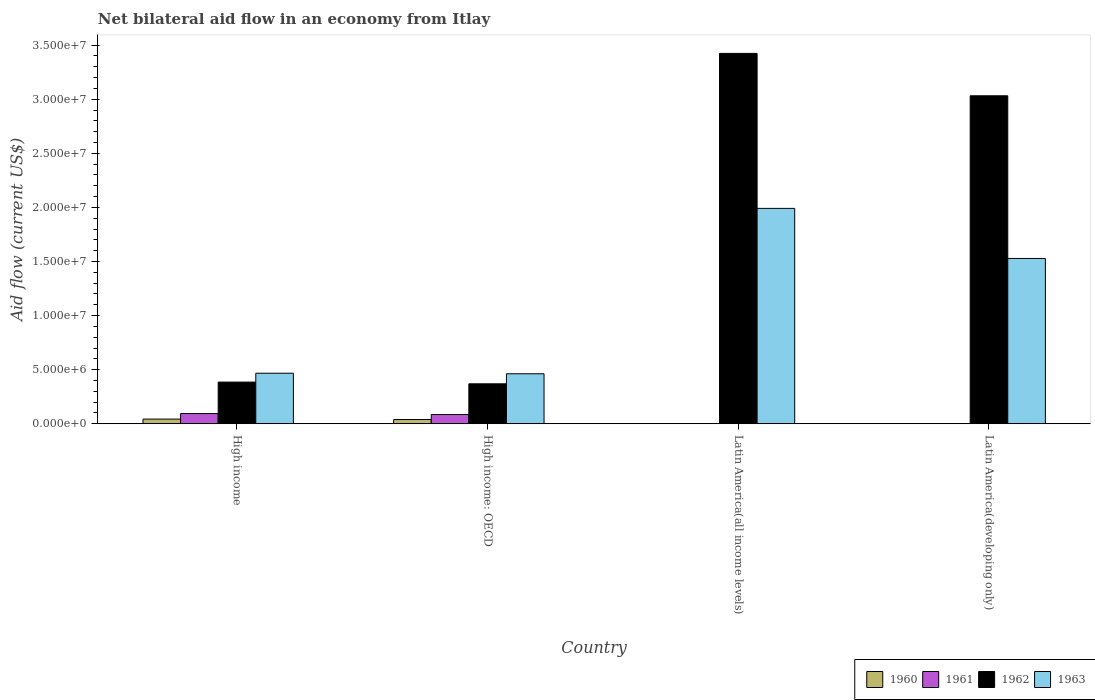How many groups of bars are there?
Offer a very short reply. 4. Are the number of bars per tick equal to the number of legend labels?
Keep it short and to the point. No. How many bars are there on the 1st tick from the left?
Provide a succinct answer. 4. How many bars are there on the 2nd tick from the right?
Provide a short and direct response. 2. What is the label of the 3rd group of bars from the left?
Provide a succinct answer. Latin America(all income levels). In how many cases, is the number of bars for a given country not equal to the number of legend labels?
Your response must be concise. 2. What is the net bilateral aid flow in 1963 in High income?
Your response must be concise. 4.67e+06. Across all countries, what is the maximum net bilateral aid flow in 1962?
Your response must be concise. 3.42e+07. Across all countries, what is the minimum net bilateral aid flow in 1960?
Your response must be concise. 0. In which country was the net bilateral aid flow in 1962 maximum?
Provide a short and direct response. Latin America(all income levels). What is the total net bilateral aid flow in 1962 in the graph?
Give a very brief answer. 7.21e+07. What is the difference between the net bilateral aid flow in 1961 in High income and that in High income: OECD?
Your answer should be compact. 9.00e+04. What is the difference between the net bilateral aid flow in 1962 in Latin America(developing only) and the net bilateral aid flow in 1961 in High income: OECD?
Provide a succinct answer. 2.95e+07. What is the average net bilateral aid flow in 1961 per country?
Offer a very short reply. 4.48e+05. What is the difference between the net bilateral aid flow of/in 1963 and net bilateral aid flow of/in 1962 in High income?
Keep it short and to the point. 8.20e+05. In how many countries, is the net bilateral aid flow in 1961 greater than 25000000 US$?
Your answer should be compact. 0. What is the ratio of the net bilateral aid flow in 1962 in High income to that in Latin America(developing only)?
Offer a terse response. 0.13. Is the net bilateral aid flow in 1960 in High income less than that in High income: OECD?
Offer a very short reply. No. What is the difference between the highest and the second highest net bilateral aid flow in 1962?
Your answer should be very brief. 3.04e+07. What is the difference between the highest and the lowest net bilateral aid flow in 1962?
Provide a succinct answer. 3.06e+07. Is the sum of the net bilateral aid flow in 1962 in High income and Latin America(all income levels) greater than the maximum net bilateral aid flow in 1963 across all countries?
Ensure brevity in your answer.  Yes. Is it the case that in every country, the sum of the net bilateral aid flow in 1963 and net bilateral aid flow in 1960 is greater than the sum of net bilateral aid flow in 1961 and net bilateral aid flow in 1962?
Make the answer very short. No. Is it the case that in every country, the sum of the net bilateral aid flow in 1963 and net bilateral aid flow in 1961 is greater than the net bilateral aid flow in 1960?
Give a very brief answer. Yes. Are all the bars in the graph horizontal?
Provide a succinct answer. No. How many countries are there in the graph?
Your answer should be very brief. 4. What is the difference between two consecutive major ticks on the Y-axis?
Ensure brevity in your answer.  5.00e+06. Does the graph contain any zero values?
Provide a succinct answer. Yes. How many legend labels are there?
Offer a very short reply. 4. How are the legend labels stacked?
Offer a terse response. Horizontal. What is the title of the graph?
Your response must be concise. Net bilateral aid flow in an economy from Itlay. What is the label or title of the X-axis?
Offer a very short reply. Country. What is the label or title of the Y-axis?
Your answer should be compact. Aid flow (current US$). What is the Aid flow (current US$) of 1960 in High income?
Your response must be concise. 4.30e+05. What is the Aid flow (current US$) of 1961 in High income?
Provide a succinct answer. 9.40e+05. What is the Aid flow (current US$) of 1962 in High income?
Offer a very short reply. 3.85e+06. What is the Aid flow (current US$) of 1963 in High income?
Offer a terse response. 4.67e+06. What is the Aid flow (current US$) of 1961 in High income: OECD?
Offer a very short reply. 8.50e+05. What is the Aid flow (current US$) of 1962 in High income: OECD?
Offer a very short reply. 3.69e+06. What is the Aid flow (current US$) in 1963 in High income: OECD?
Your response must be concise. 4.62e+06. What is the Aid flow (current US$) in 1961 in Latin America(all income levels)?
Give a very brief answer. 0. What is the Aid flow (current US$) in 1962 in Latin America(all income levels)?
Make the answer very short. 3.42e+07. What is the Aid flow (current US$) in 1963 in Latin America(all income levels)?
Offer a very short reply. 1.99e+07. What is the Aid flow (current US$) in 1960 in Latin America(developing only)?
Keep it short and to the point. 0. What is the Aid flow (current US$) in 1962 in Latin America(developing only)?
Make the answer very short. 3.03e+07. What is the Aid flow (current US$) in 1963 in Latin America(developing only)?
Keep it short and to the point. 1.53e+07. Across all countries, what is the maximum Aid flow (current US$) of 1961?
Give a very brief answer. 9.40e+05. Across all countries, what is the maximum Aid flow (current US$) in 1962?
Offer a very short reply. 3.42e+07. Across all countries, what is the maximum Aid flow (current US$) of 1963?
Ensure brevity in your answer.  1.99e+07. Across all countries, what is the minimum Aid flow (current US$) of 1960?
Keep it short and to the point. 0. Across all countries, what is the minimum Aid flow (current US$) in 1962?
Offer a terse response. 3.69e+06. Across all countries, what is the minimum Aid flow (current US$) in 1963?
Your response must be concise. 4.62e+06. What is the total Aid flow (current US$) in 1960 in the graph?
Provide a short and direct response. 8.20e+05. What is the total Aid flow (current US$) of 1961 in the graph?
Ensure brevity in your answer.  1.79e+06. What is the total Aid flow (current US$) in 1962 in the graph?
Provide a succinct answer. 7.21e+07. What is the total Aid flow (current US$) of 1963 in the graph?
Your answer should be compact. 4.45e+07. What is the difference between the Aid flow (current US$) in 1960 in High income and that in High income: OECD?
Make the answer very short. 4.00e+04. What is the difference between the Aid flow (current US$) of 1961 in High income and that in High income: OECD?
Your answer should be very brief. 9.00e+04. What is the difference between the Aid flow (current US$) of 1962 in High income and that in High income: OECD?
Ensure brevity in your answer.  1.60e+05. What is the difference between the Aid flow (current US$) of 1963 in High income and that in High income: OECD?
Offer a terse response. 5.00e+04. What is the difference between the Aid flow (current US$) in 1962 in High income and that in Latin America(all income levels)?
Provide a short and direct response. -3.04e+07. What is the difference between the Aid flow (current US$) in 1963 in High income and that in Latin America(all income levels)?
Give a very brief answer. -1.52e+07. What is the difference between the Aid flow (current US$) of 1962 in High income and that in Latin America(developing only)?
Offer a terse response. -2.65e+07. What is the difference between the Aid flow (current US$) in 1963 in High income and that in Latin America(developing only)?
Make the answer very short. -1.06e+07. What is the difference between the Aid flow (current US$) of 1962 in High income: OECD and that in Latin America(all income levels)?
Your answer should be very brief. -3.06e+07. What is the difference between the Aid flow (current US$) of 1963 in High income: OECD and that in Latin America(all income levels)?
Offer a terse response. -1.53e+07. What is the difference between the Aid flow (current US$) of 1962 in High income: OECD and that in Latin America(developing only)?
Make the answer very short. -2.66e+07. What is the difference between the Aid flow (current US$) in 1963 in High income: OECD and that in Latin America(developing only)?
Provide a short and direct response. -1.07e+07. What is the difference between the Aid flow (current US$) in 1962 in Latin America(all income levels) and that in Latin America(developing only)?
Give a very brief answer. 3.92e+06. What is the difference between the Aid flow (current US$) of 1963 in Latin America(all income levels) and that in Latin America(developing only)?
Offer a terse response. 4.63e+06. What is the difference between the Aid flow (current US$) of 1960 in High income and the Aid flow (current US$) of 1961 in High income: OECD?
Give a very brief answer. -4.20e+05. What is the difference between the Aid flow (current US$) in 1960 in High income and the Aid flow (current US$) in 1962 in High income: OECD?
Offer a very short reply. -3.26e+06. What is the difference between the Aid flow (current US$) of 1960 in High income and the Aid flow (current US$) of 1963 in High income: OECD?
Give a very brief answer. -4.19e+06. What is the difference between the Aid flow (current US$) in 1961 in High income and the Aid flow (current US$) in 1962 in High income: OECD?
Your response must be concise. -2.75e+06. What is the difference between the Aid flow (current US$) in 1961 in High income and the Aid flow (current US$) in 1963 in High income: OECD?
Make the answer very short. -3.68e+06. What is the difference between the Aid flow (current US$) of 1962 in High income and the Aid flow (current US$) of 1963 in High income: OECD?
Your response must be concise. -7.70e+05. What is the difference between the Aid flow (current US$) in 1960 in High income and the Aid flow (current US$) in 1962 in Latin America(all income levels)?
Provide a short and direct response. -3.38e+07. What is the difference between the Aid flow (current US$) of 1960 in High income and the Aid flow (current US$) of 1963 in Latin America(all income levels)?
Provide a succinct answer. -1.95e+07. What is the difference between the Aid flow (current US$) of 1961 in High income and the Aid flow (current US$) of 1962 in Latin America(all income levels)?
Your response must be concise. -3.33e+07. What is the difference between the Aid flow (current US$) of 1961 in High income and the Aid flow (current US$) of 1963 in Latin America(all income levels)?
Offer a very short reply. -1.90e+07. What is the difference between the Aid flow (current US$) of 1962 in High income and the Aid flow (current US$) of 1963 in Latin America(all income levels)?
Provide a succinct answer. -1.61e+07. What is the difference between the Aid flow (current US$) of 1960 in High income and the Aid flow (current US$) of 1962 in Latin America(developing only)?
Your response must be concise. -2.99e+07. What is the difference between the Aid flow (current US$) in 1960 in High income and the Aid flow (current US$) in 1963 in Latin America(developing only)?
Provide a short and direct response. -1.48e+07. What is the difference between the Aid flow (current US$) in 1961 in High income and the Aid flow (current US$) in 1962 in Latin America(developing only)?
Offer a terse response. -2.94e+07. What is the difference between the Aid flow (current US$) in 1961 in High income and the Aid flow (current US$) in 1963 in Latin America(developing only)?
Provide a succinct answer. -1.43e+07. What is the difference between the Aid flow (current US$) of 1962 in High income and the Aid flow (current US$) of 1963 in Latin America(developing only)?
Your answer should be compact. -1.14e+07. What is the difference between the Aid flow (current US$) of 1960 in High income: OECD and the Aid flow (current US$) of 1962 in Latin America(all income levels)?
Make the answer very short. -3.38e+07. What is the difference between the Aid flow (current US$) in 1960 in High income: OECD and the Aid flow (current US$) in 1963 in Latin America(all income levels)?
Give a very brief answer. -1.95e+07. What is the difference between the Aid flow (current US$) in 1961 in High income: OECD and the Aid flow (current US$) in 1962 in Latin America(all income levels)?
Offer a terse response. -3.34e+07. What is the difference between the Aid flow (current US$) in 1961 in High income: OECD and the Aid flow (current US$) in 1963 in Latin America(all income levels)?
Your answer should be very brief. -1.91e+07. What is the difference between the Aid flow (current US$) in 1962 in High income: OECD and the Aid flow (current US$) in 1963 in Latin America(all income levels)?
Provide a succinct answer. -1.62e+07. What is the difference between the Aid flow (current US$) in 1960 in High income: OECD and the Aid flow (current US$) in 1962 in Latin America(developing only)?
Provide a succinct answer. -2.99e+07. What is the difference between the Aid flow (current US$) in 1960 in High income: OECD and the Aid flow (current US$) in 1963 in Latin America(developing only)?
Provide a succinct answer. -1.49e+07. What is the difference between the Aid flow (current US$) of 1961 in High income: OECD and the Aid flow (current US$) of 1962 in Latin America(developing only)?
Provide a short and direct response. -2.95e+07. What is the difference between the Aid flow (current US$) of 1961 in High income: OECD and the Aid flow (current US$) of 1963 in Latin America(developing only)?
Your answer should be compact. -1.44e+07. What is the difference between the Aid flow (current US$) of 1962 in High income: OECD and the Aid flow (current US$) of 1963 in Latin America(developing only)?
Your answer should be very brief. -1.16e+07. What is the difference between the Aid flow (current US$) in 1962 in Latin America(all income levels) and the Aid flow (current US$) in 1963 in Latin America(developing only)?
Offer a very short reply. 1.90e+07. What is the average Aid flow (current US$) of 1960 per country?
Provide a succinct answer. 2.05e+05. What is the average Aid flow (current US$) of 1961 per country?
Give a very brief answer. 4.48e+05. What is the average Aid flow (current US$) of 1962 per country?
Keep it short and to the point. 1.80e+07. What is the average Aid flow (current US$) of 1963 per country?
Your answer should be compact. 1.11e+07. What is the difference between the Aid flow (current US$) of 1960 and Aid flow (current US$) of 1961 in High income?
Offer a terse response. -5.10e+05. What is the difference between the Aid flow (current US$) in 1960 and Aid flow (current US$) in 1962 in High income?
Offer a very short reply. -3.42e+06. What is the difference between the Aid flow (current US$) in 1960 and Aid flow (current US$) in 1963 in High income?
Your response must be concise. -4.24e+06. What is the difference between the Aid flow (current US$) of 1961 and Aid flow (current US$) of 1962 in High income?
Make the answer very short. -2.91e+06. What is the difference between the Aid flow (current US$) in 1961 and Aid flow (current US$) in 1963 in High income?
Provide a succinct answer. -3.73e+06. What is the difference between the Aid flow (current US$) of 1962 and Aid flow (current US$) of 1963 in High income?
Provide a succinct answer. -8.20e+05. What is the difference between the Aid flow (current US$) in 1960 and Aid flow (current US$) in 1961 in High income: OECD?
Your answer should be very brief. -4.60e+05. What is the difference between the Aid flow (current US$) in 1960 and Aid flow (current US$) in 1962 in High income: OECD?
Provide a short and direct response. -3.30e+06. What is the difference between the Aid flow (current US$) in 1960 and Aid flow (current US$) in 1963 in High income: OECD?
Provide a short and direct response. -4.23e+06. What is the difference between the Aid flow (current US$) of 1961 and Aid flow (current US$) of 1962 in High income: OECD?
Provide a succinct answer. -2.84e+06. What is the difference between the Aid flow (current US$) of 1961 and Aid flow (current US$) of 1963 in High income: OECD?
Give a very brief answer. -3.77e+06. What is the difference between the Aid flow (current US$) of 1962 and Aid flow (current US$) of 1963 in High income: OECD?
Offer a terse response. -9.30e+05. What is the difference between the Aid flow (current US$) of 1962 and Aid flow (current US$) of 1963 in Latin America(all income levels)?
Your answer should be very brief. 1.43e+07. What is the difference between the Aid flow (current US$) in 1962 and Aid flow (current US$) in 1963 in Latin America(developing only)?
Your answer should be compact. 1.50e+07. What is the ratio of the Aid flow (current US$) of 1960 in High income to that in High income: OECD?
Make the answer very short. 1.1. What is the ratio of the Aid flow (current US$) of 1961 in High income to that in High income: OECD?
Ensure brevity in your answer.  1.11. What is the ratio of the Aid flow (current US$) of 1962 in High income to that in High income: OECD?
Give a very brief answer. 1.04. What is the ratio of the Aid flow (current US$) of 1963 in High income to that in High income: OECD?
Offer a terse response. 1.01. What is the ratio of the Aid flow (current US$) of 1962 in High income to that in Latin America(all income levels)?
Ensure brevity in your answer.  0.11. What is the ratio of the Aid flow (current US$) of 1963 in High income to that in Latin America(all income levels)?
Make the answer very short. 0.23. What is the ratio of the Aid flow (current US$) of 1962 in High income to that in Latin America(developing only)?
Your answer should be compact. 0.13. What is the ratio of the Aid flow (current US$) in 1963 in High income to that in Latin America(developing only)?
Give a very brief answer. 0.31. What is the ratio of the Aid flow (current US$) of 1962 in High income: OECD to that in Latin America(all income levels)?
Ensure brevity in your answer.  0.11. What is the ratio of the Aid flow (current US$) in 1963 in High income: OECD to that in Latin America(all income levels)?
Keep it short and to the point. 0.23. What is the ratio of the Aid flow (current US$) in 1962 in High income: OECD to that in Latin America(developing only)?
Your response must be concise. 0.12. What is the ratio of the Aid flow (current US$) in 1963 in High income: OECD to that in Latin America(developing only)?
Your response must be concise. 0.3. What is the ratio of the Aid flow (current US$) in 1962 in Latin America(all income levels) to that in Latin America(developing only)?
Your answer should be compact. 1.13. What is the ratio of the Aid flow (current US$) in 1963 in Latin America(all income levels) to that in Latin America(developing only)?
Offer a very short reply. 1.3. What is the difference between the highest and the second highest Aid flow (current US$) of 1962?
Your answer should be very brief. 3.92e+06. What is the difference between the highest and the second highest Aid flow (current US$) of 1963?
Keep it short and to the point. 4.63e+06. What is the difference between the highest and the lowest Aid flow (current US$) in 1961?
Provide a short and direct response. 9.40e+05. What is the difference between the highest and the lowest Aid flow (current US$) of 1962?
Provide a short and direct response. 3.06e+07. What is the difference between the highest and the lowest Aid flow (current US$) in 1963?
Your answer should be very brief. 1.53e+07. 